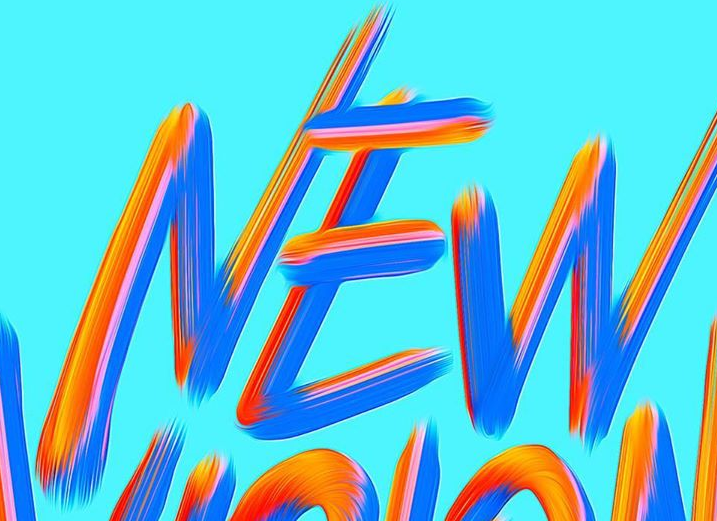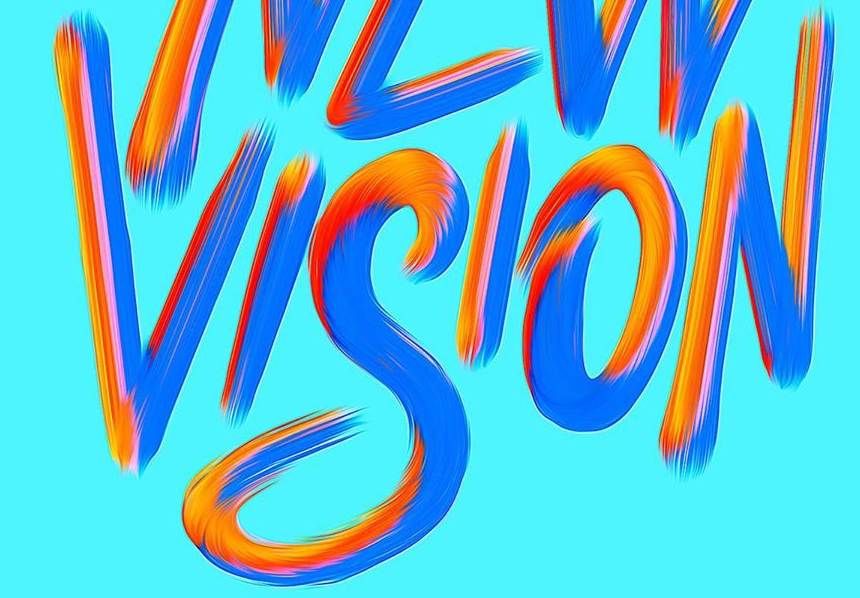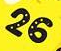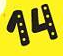Read the text content from these images in order, separated by a semicolon. NEW; VISION; 26; 14 